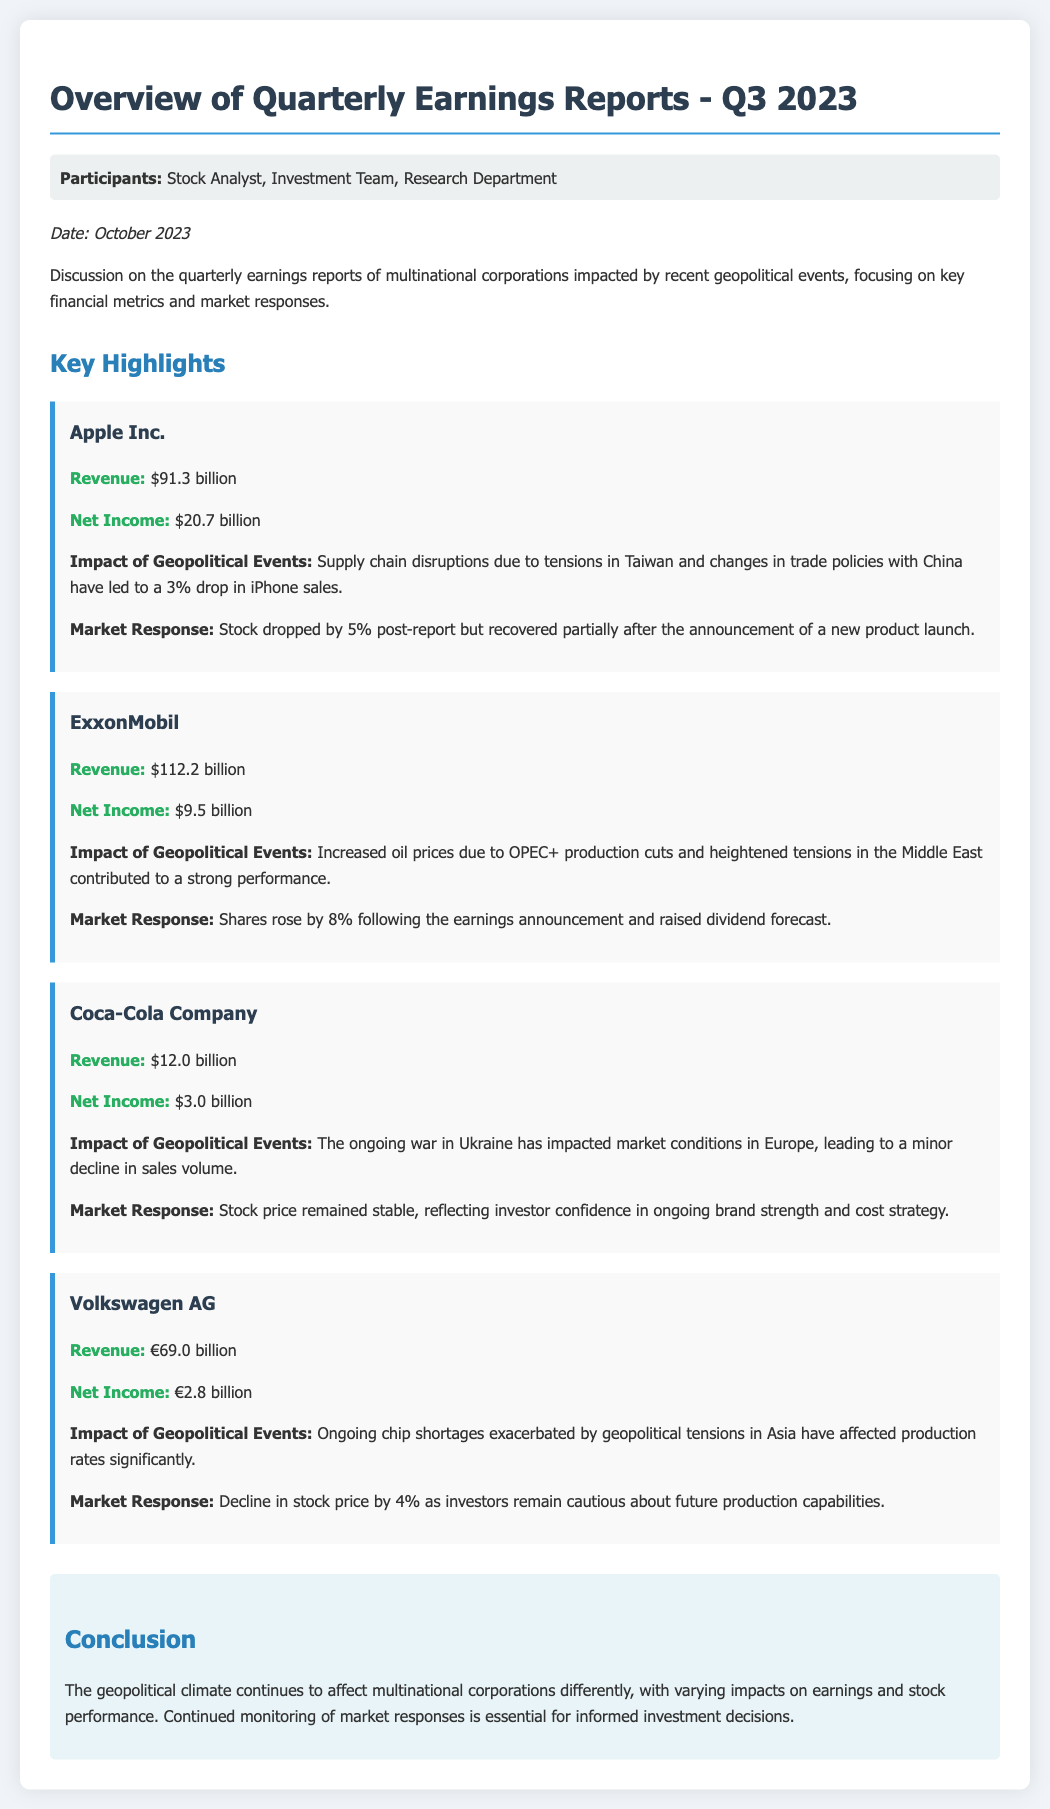What was Apple's revenue for Q3 2023? The revenue of Apple Inc. is stated in the document as $91.3 billion.
Answer: $91.3 billion How much net income did ExxonMobil report? The document specifies ExxonMobil's net income as $9.5 billion.
Answer: $9.5 billion What was the percentage drop in iPhone sales for Apple due to geopolitical events? The document mentions a 3% drop in iPhone sales attributed to geopolitical events.
Answer: 3% What was the market response for Coca-Cola's stock price? The document indicates that Coca-Cola's stock price remained stable.
Answer: Stable What caused the strong performance of ExxonMobil in Q3 2023? The document states that increased oil prices due to OPEC+ production cuts and heightened tensions in the Middle East contributed to ExxonMobil's strong performance.
Answer: Increased oil prices What was Volkswagen's net income in euros for Q3 2023? The net income reported for Volkswagen AG is €2.8 billion.
Answer: €2.8 billion What event impacted Coca-Cola's market conditions in Europe? The ongoing war in Ukraine is mentioned as affecting Coca-Cola's market conditions in Europe.
Answer: War in Ukraine How much did ExxonMobil's shares rise after the earnings announcement? The document states that ExxonMobil's shares rose by 8% following the earnings announcement.
Answer: 8% What is the date of the meeting discussing the quarterly earnings...? The document notes that the date is October 2023.
Answer: October 2023 